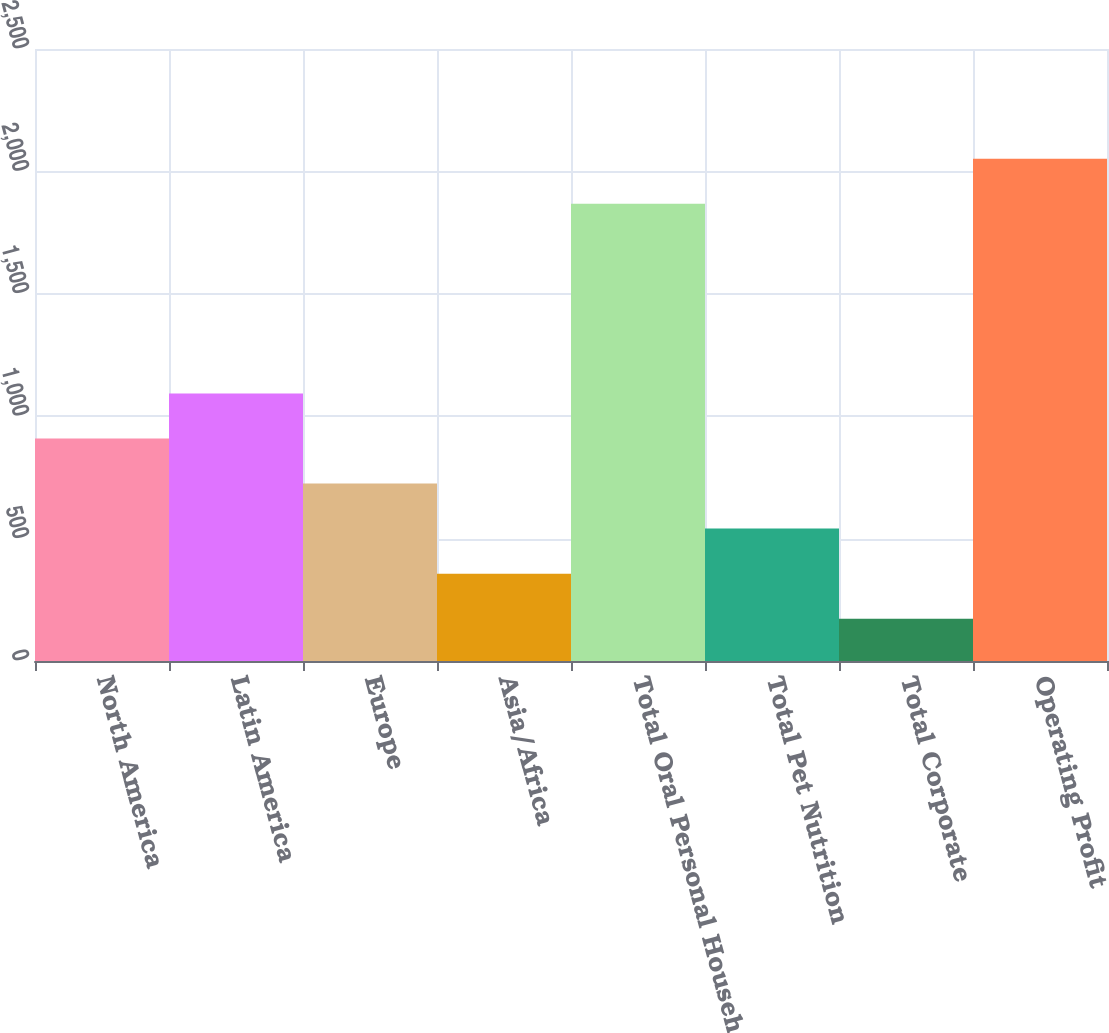Convert chart. <chart><loc_0><loc_0><loc_500><loc_500><bar_chart><fcel>North America<fcel>Latin America<fcel>Europe<fcel>Asia/Africa<fcel>Total Oral Personal Household<fcel>Total Pet Nutrition<fcel>Total Corporate<fcel>Operating Profit<nl><fcel>908.98<fcel>1093<fcel>724.96<fcel>356.92<fcel>1867.7<fcel>540.94<fcel>172.9<fcel>2051.72<nl></chart> 